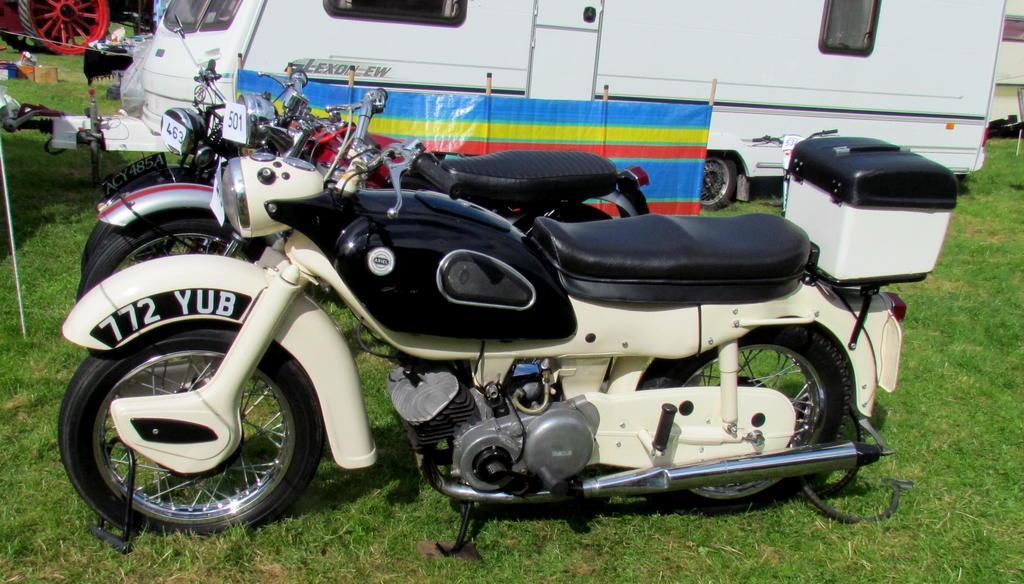In one or two sentences, can you explain what this image depicts? In the picture there are many vehicles present on the ground, there is grass. 